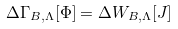<formula> <loc_0><loc_0><loc_500><loc_500>\Delta \Gamma _ { B , \Lambda } [ \Phi ] = \Delta W _ { B , \Lambda } [ J ]</formula> 